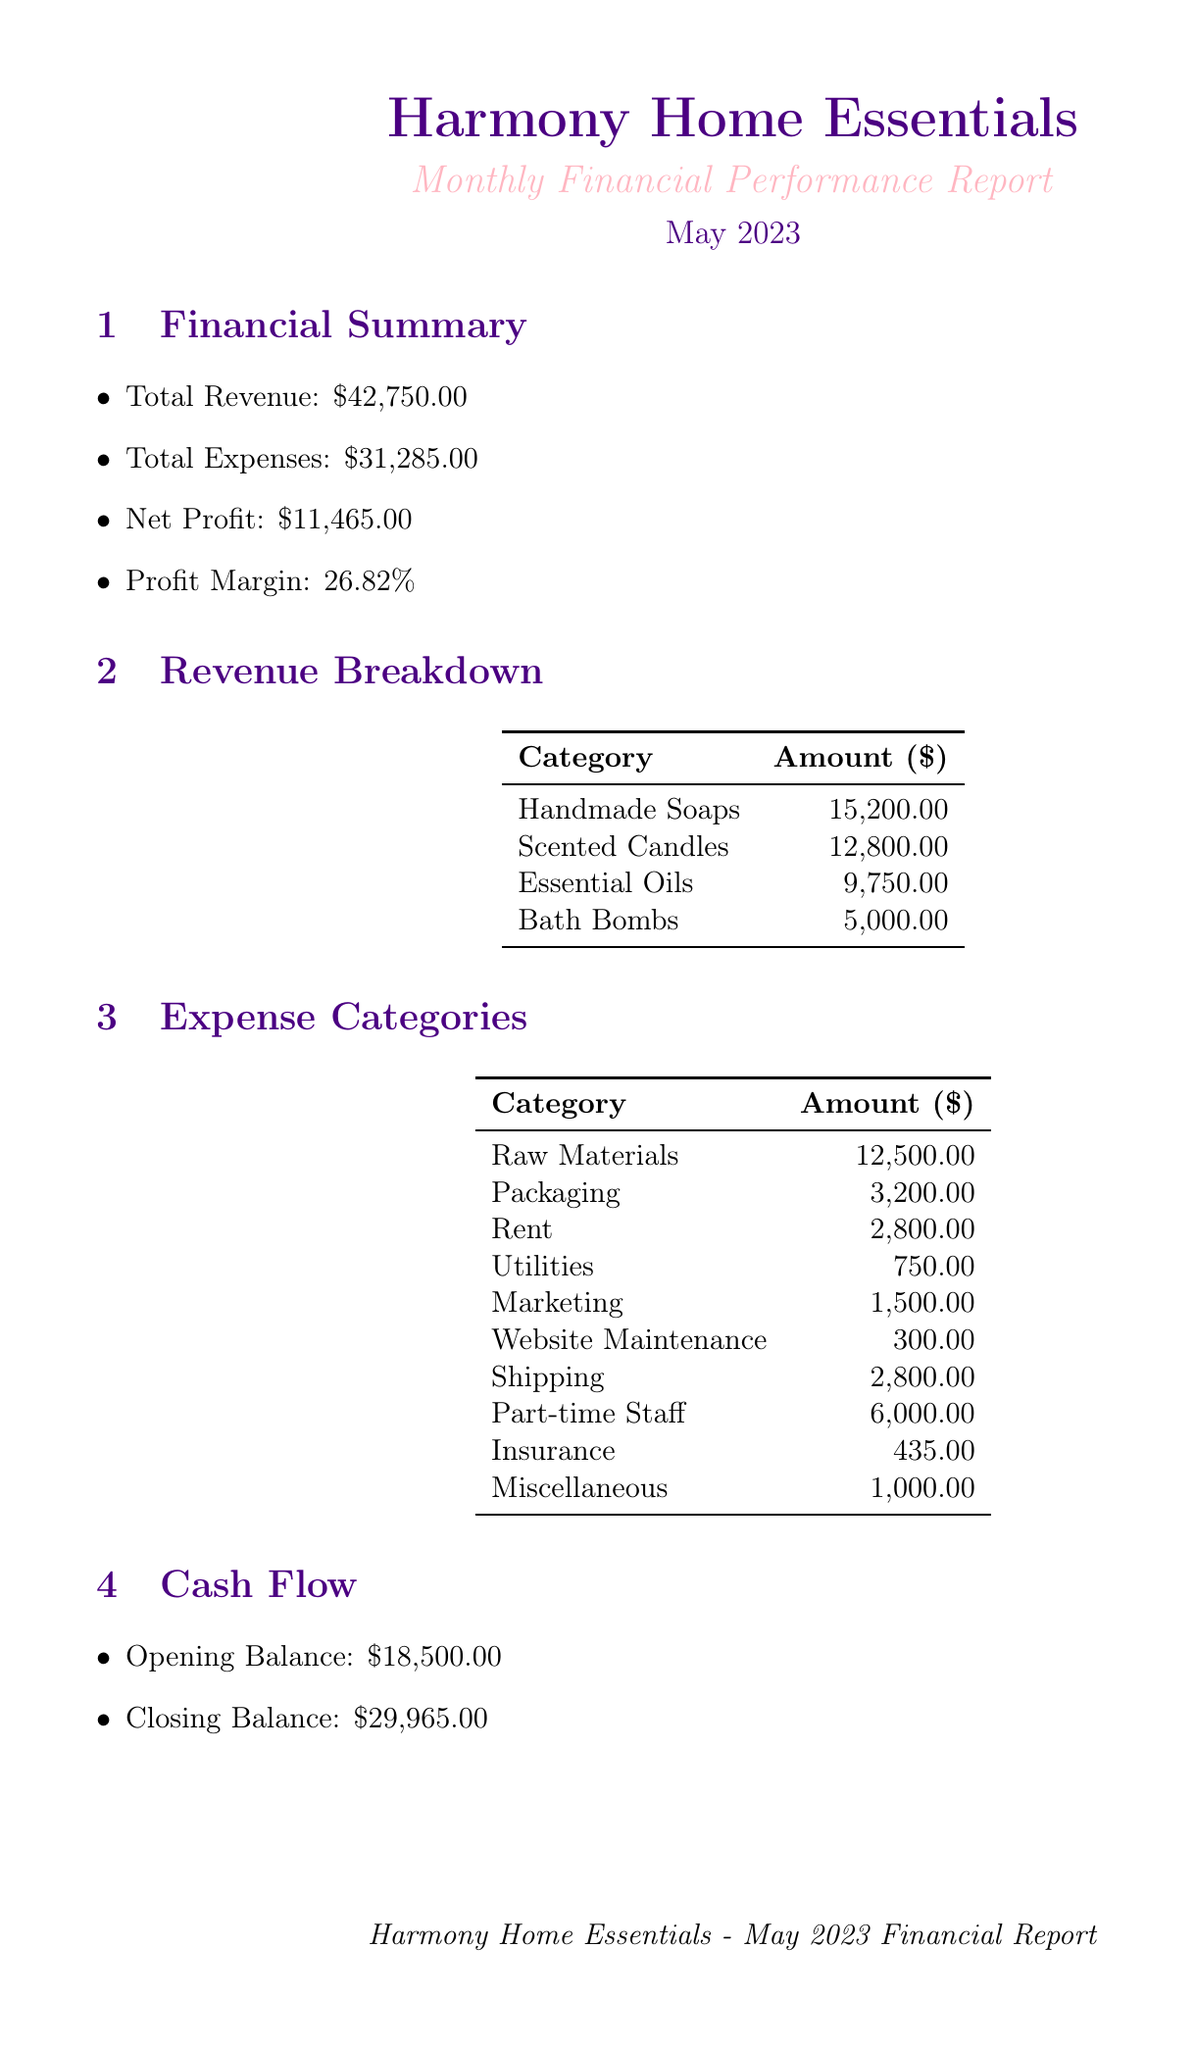What is the total revenue? The total revenue is stated in the financial summary section, which shows it as $42,750.00.
Answer: $42,750.00 What are the total expenses? Total expenses are specified in the financial summary section, which indicates it as $31,285.00.
Answer: $31,285.00 What is the net profit for May 2023? The net profit is derived from the financial summary, which reports it as $11,465.00.
Answer: $11,465.00 What is the profit margin percentage? The profit margin is calculated in the financial summary section, listed as 26.82%.
Answer: 26.82% Which category generated the highest revenue? Revenue breakdown indicates that Handmade Soaps earned the most revenue, amounting to $15,200.00.
Answer: Handmade Soaps What is the average order value? The average order value is noted in the key metrics section, which shows it as $65.00.
Answer: $65.00 How many new customers were acquired? Customer acquisition information reveals that the number of new customers is 180.
Answer: 180 What is one goal for the business? The goals section lists several objectives, one of which is to increase profit margin to 30%.
Answer: Increase profit margin to 30% What is one challenge faced by the business? The challenges section mentions several issues, one being rising raw material costs due to supply chain issues.
Answer: Rising raw material costs What is one positive point from the director's feedback? The director's feedback section highlights positives, for example, impressive revenue growth compared to last month.
Answer: Impressive revenue growth 